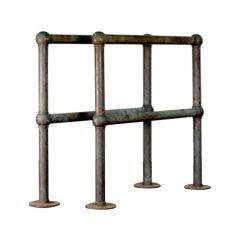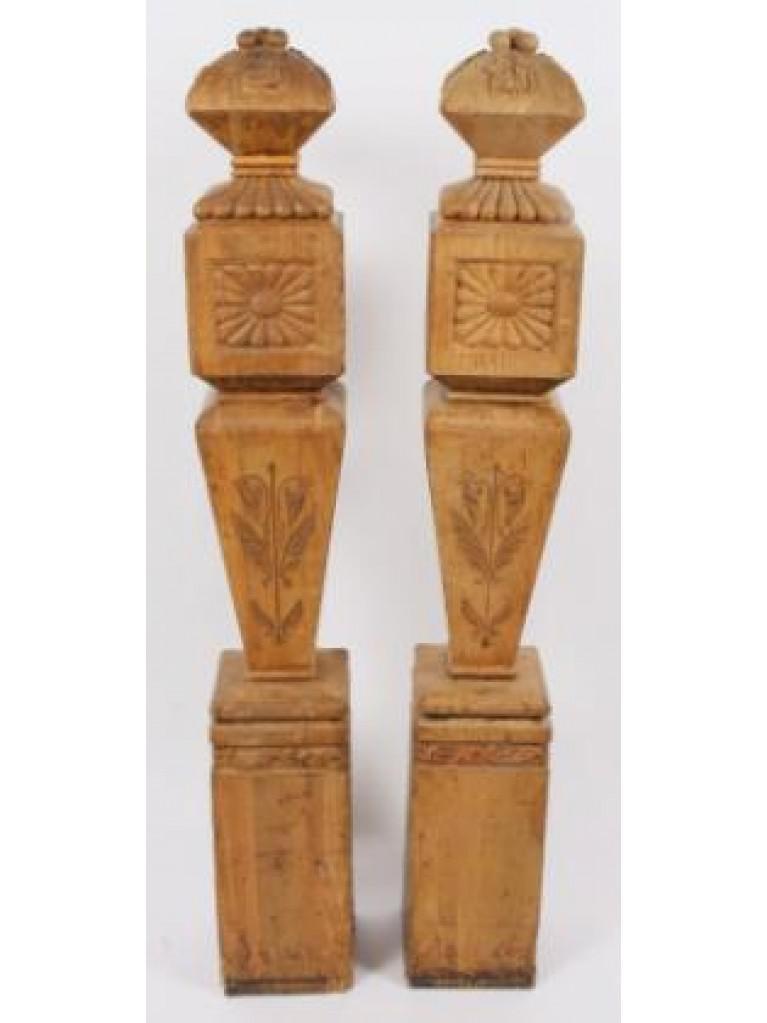The first image is the image on the left, the second image is the image on the right. Analyze the images presented: Is the assertion "In at least one image one of the row have seven  wooden rails." valid? Answer yes or no. No. 